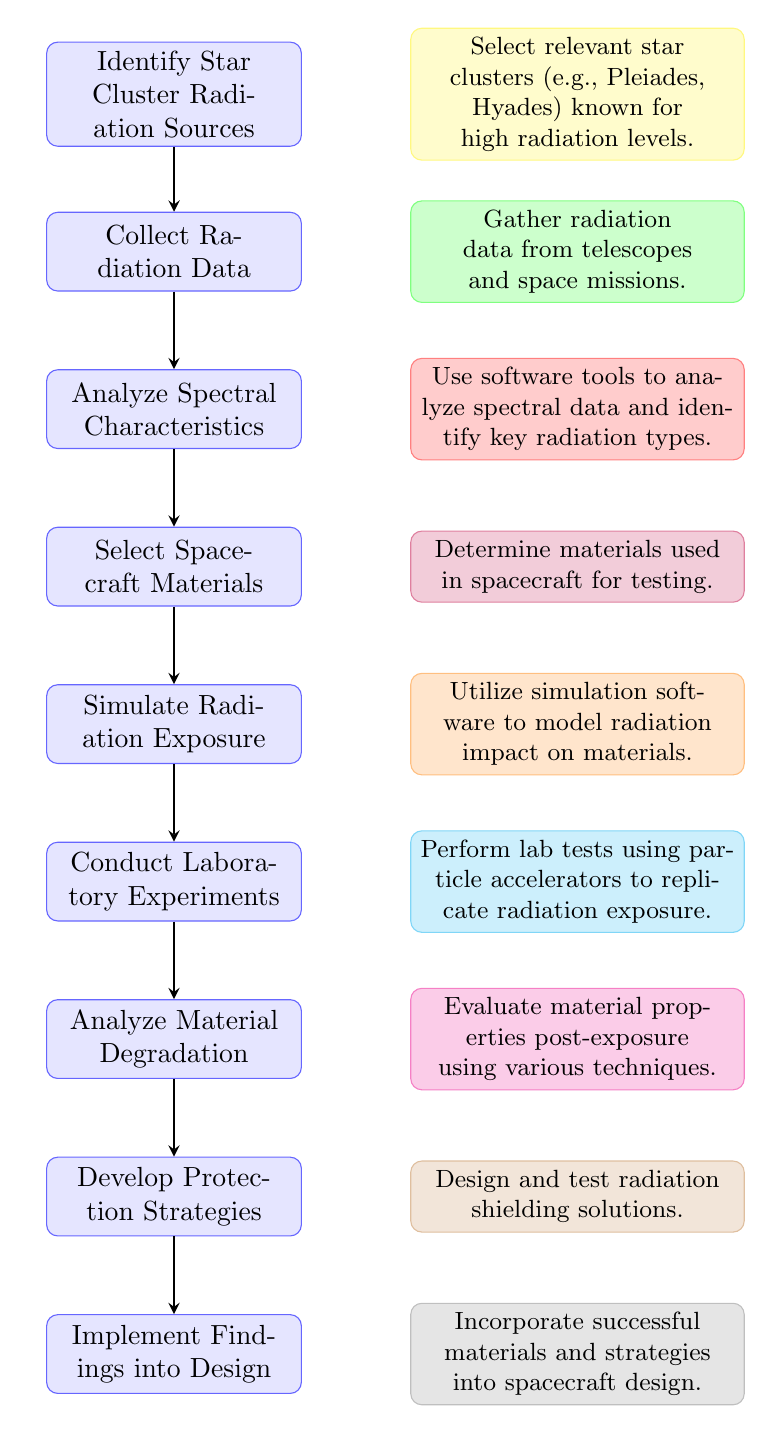What is the first step in the workflow? The first step is represented as the top node in the flow chart which states "Identify Star Cluster Radiation Sources." It is the initial point in the analysis process.
Answer: Identify Star Cluster Radiation Sources How many total nodes are in the diagram? By counting each rectangular node in the flow chart from top to bottom, there are nine distinct nodes, each representing a process in the workflow.
Answer: 9 What step follows after "Analyze Spectral Characteristics"? Following the node "Analyze Spectral Characteristics," the next step is "Select Spacecraft Materials." The flow of the diagram shows a direct connection from one process to the next.
Answer: Select Spacecraft Materials What is the last process in the flow chart? The last node in the flow chart is "Implement Findings into Design," as it's at the bottom of the diagram and indicates the final step in the workflow.
Answer: Implement Findings into Design Which two nodes are directly connected to "Simulate Radiation Exposure"? The node "Simulate Radiation Exposure" has direct connections to the nodes "Select Spacecraft Materials" (which precedes it) and "Conduct Laboratory Experiments" (which follows it). This can be identified by the arrows representing the flow of the process.
Answer: Select Spacecraft Materials and Conduct Laboratory Experiments What type of software is mentioned for simulating radiation exposure? The flow chart specifies the use of simulation software called "GEANT4, FLUKA" for modeling the impact of radiation on selected materials, as detailed in the text next to the corresponding node.
Answer: GEANT4, FLUKA What is the main focus of the laboratory experiments? The laboratory experiments aim to "Conduct Laboratory Experiments" that replicate radiation exposure using particle accelerators. This focus can be extracted from the description of that specific node in the flow chart.
Answer: Replicate radiation exposure How does material degradation analysis relate to radiation exposure? The "Analyze Material Degradation" step follows "Conduct Laboratory Experiments," indicating that the analysis of material degradation is based on the effects of the radiation exposure that was replicated in the lab tests. Therefore, it directly assesses the outcomes of those experiments.
Answer: Based on replicated radiation exposure What is one purpose of developing protection strategies? The purpose of the "Develop Protection Strategies" step is to design and test radiation shielding solutions, which is crucial for enhancing spacecraft resilience to the effects of star cluster radiation as indicated in the relevant node description.
Answer: Design and test radiation shielding solutions 